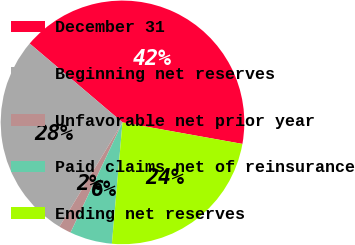Convert chart. <chart><loc_0><loc_0><loc_500><loc_500><pie_chart><fcel>December 31<fcel>Beginning net reserves<fcel>Unfavorable net prior year<fcel>Paid claims net of reinsurance<fcel>Ending net reserves<nl><fcel>41.62%<fcel>27.55%<fcel>1.64%<fcel>5.63%<fcel>23.56%<nl></chart> 